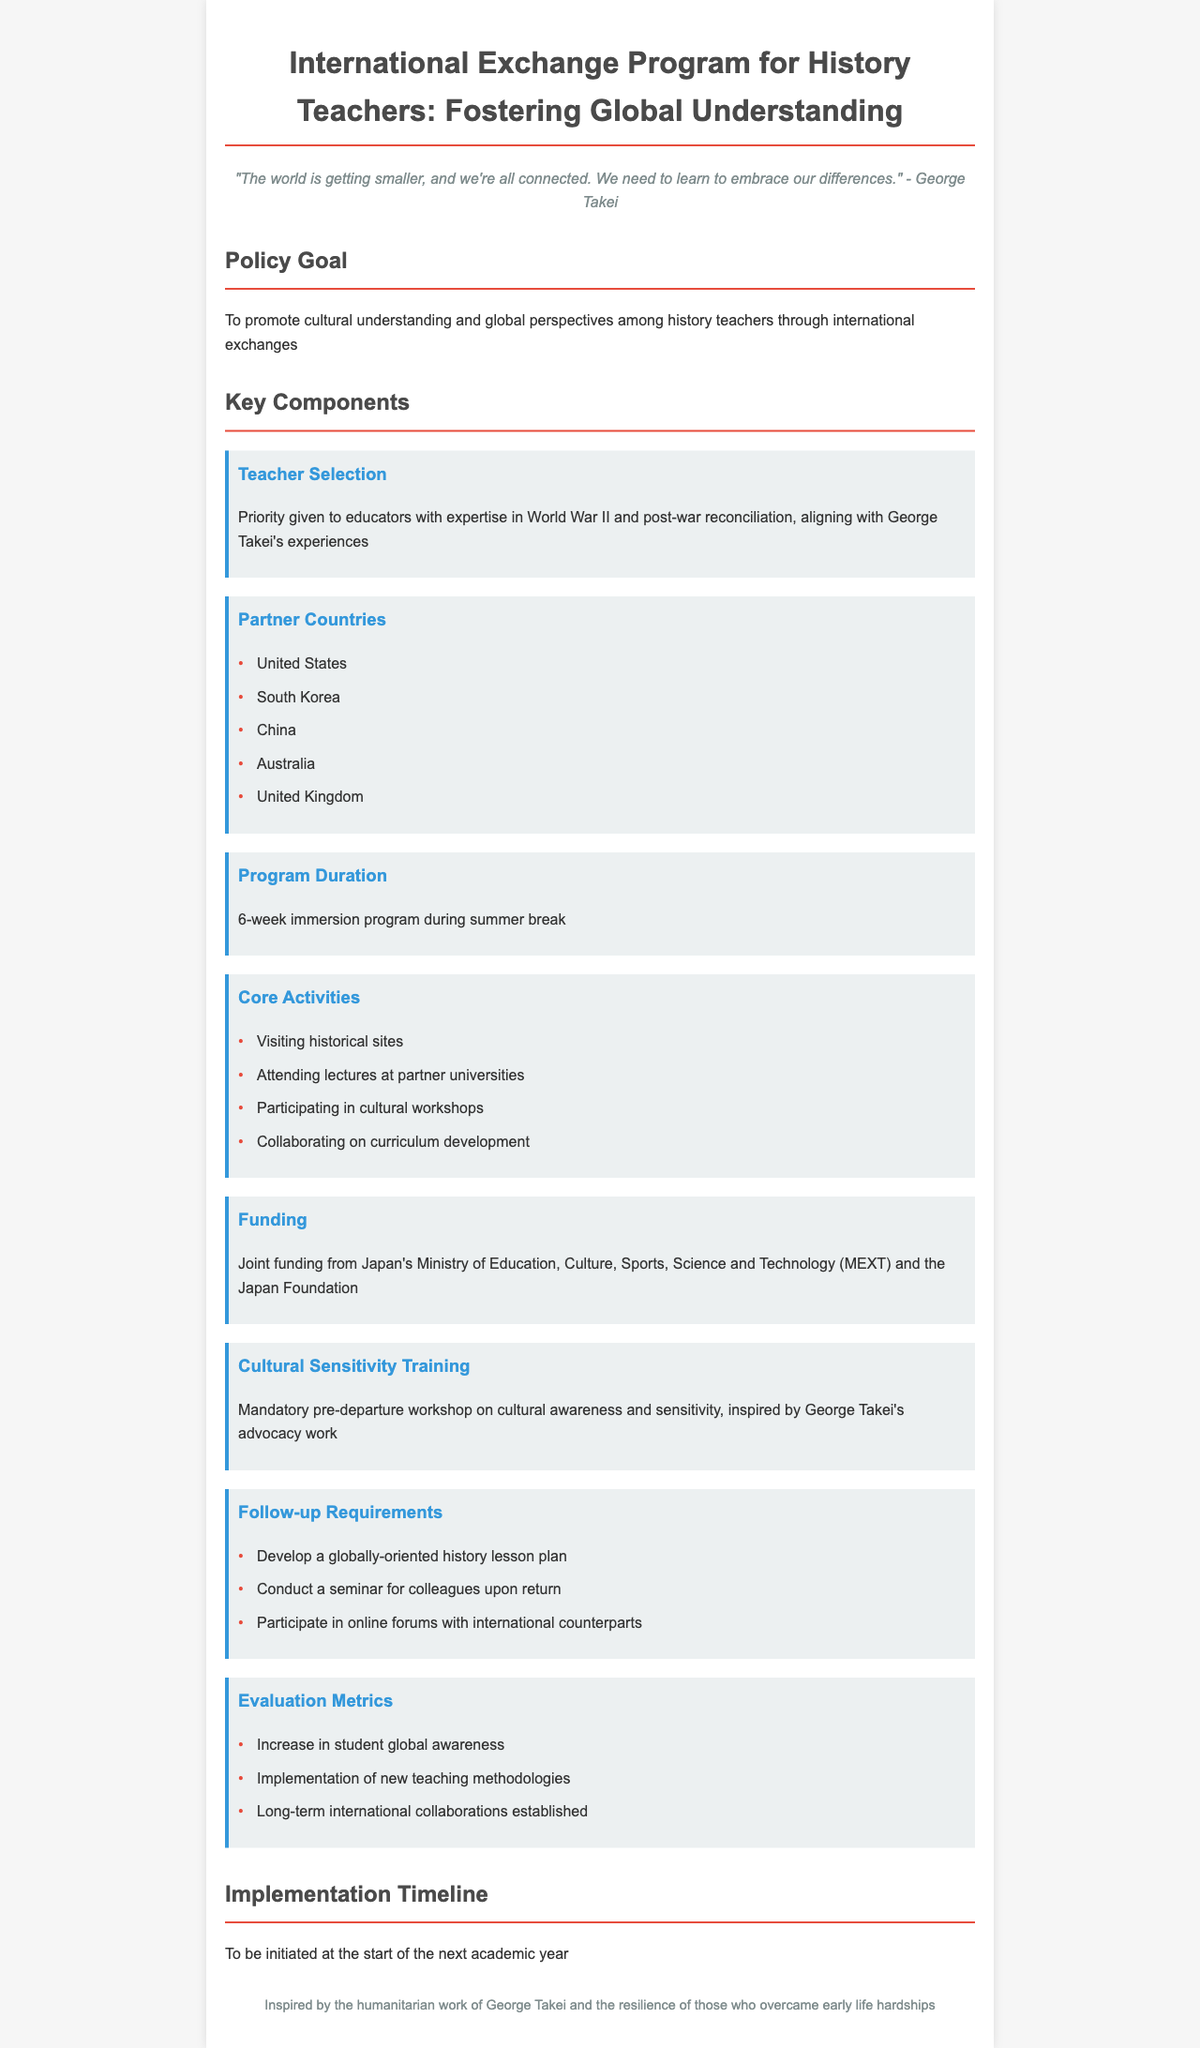What is the main goal of the policy? The policy aims to promote cultural understanding and global perspectives among history teachers through international exchanges.
Answer: To promote cultural understanding and global perspectives among history teachers through international exchanges What is the duration of the program? The duration of the program is specified in the document as 6 weeks during the summer break.
Answer: 6-week immersion program Which countries are partners in this program? The document lists partner countries which include the United States, South Korea, China, Australia, and the United Kingdom.
Answer: United States, South Korea, China, Australia, United Kingdom What mandatory training is required before departure? The document mentions a mandatory pre-departure workshop on cultural awareness and sensitivity.
Answer: Mandatory pre-departure workshop on cultural awareness and sensitivity What are teachers required to develop after returning from the program? Teachers are required to develop a globally-oriented history lesson plan upon their return.
Answer: Develop a globally-oriented history lesson plan How is the program funded? The funding source is mentioned as joint funding from Japan's Ministry of Education, Culture, Sports, Science and Technology and the Japan Foundation.
Answer: Joint funding from Japan's Ministry of Education, Culture, Sports, Science and Technology (MEXT) and the Japan Foundation What type of activities will teachers participate in? The document lists core activities including visiting historical sites and attending lectures at partner universities.
Answer: Visiting historical sites, attending lectures at partner universities, cultural workshops, collaborating on curriculum development What inspired the cultural sensitivity training? The document notes that the training is inspired by George Takei's advocacy work.
Answer: Inspired by George Takei's advocacy work 